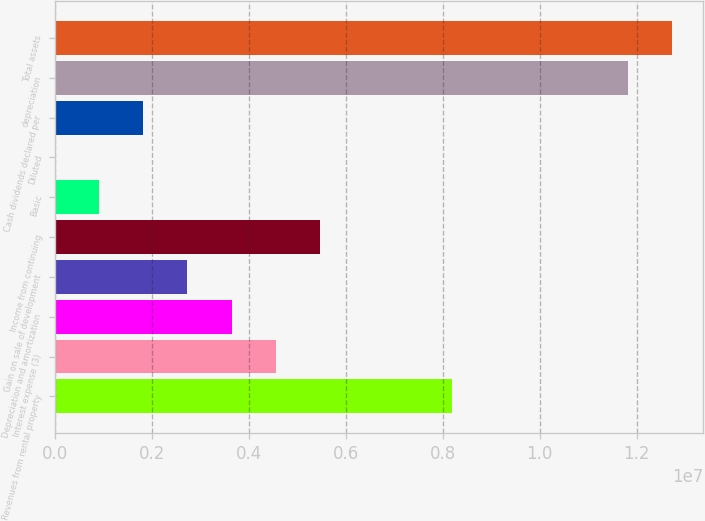Convert chart to OTSL. <chart><loc_0><loc_0><loc_500><loc_500><bar_chart><fcel>Revenues from rental property<fcel>Interest expense (3)<fcel>Depreciation and amortization<fcel>Gain on sale of development<fcel>Income from continuing<fcel>Basic<fcel>Diluted<fcel>Cash dividends declared per<fcel>depreciation<fcel>Total assets<nl><fcel>8.18803e+06<fcel>4.54891e+06<fcel>3.63913e+06<fcel>2.72935e+06<fcel>5.45869e+06<fcel>909783<fcel>1.32<fcel>1.81956e+06<fcel>1.18272e+07<fcel>1.27369e+07<nl></chart> 